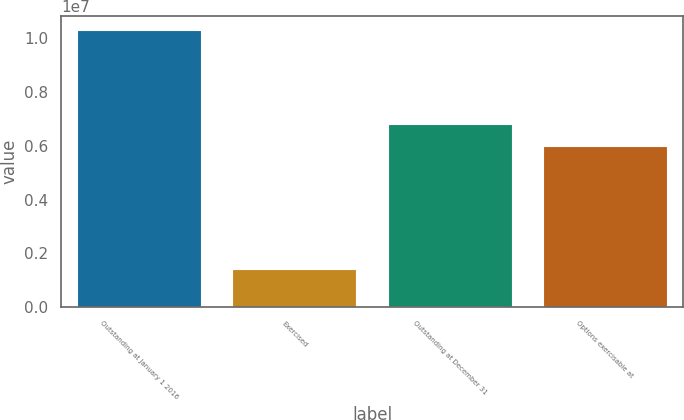<chart> <loc_0><loc_0><loc_500><loc_500><bar_chart><fcel>Outstanding at January 1 2016<fcel>Exercised<fcel>Outstanding at December 31<fcel>Options exercisable at<nl><fcel>1.03125e+07<fcel>1.4098e+06<fcel>6.82005e+06<fcel>5.99534e+06<nl></chart> 